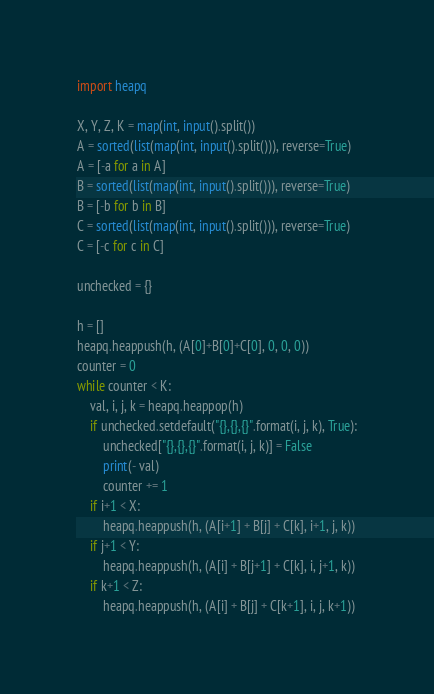<code> <loc_0><loc_0><loc_500><loc_500><_Python_>import heapq

X, Y, Z, K = map(int, input().split())
A = sorted(list(map(int, input().split())), reverse=True)
A = [-a for a in A]
B = sorted(list(map(int, input().split())), reverse=True)
B = [-b for b in B]
C = sorted(list(map(int, input().split())), reverse=True)
C = [-c for c in C]

unchecked = {}

h = []
heapq.heappush(h, (A[0]+B[0]+C[0], 0, 0, 0))
counter = 0
while counter < K:
    val, i, j, k = heapq.heappop(h)
    if unchecked.setdefault("{},{},{}".format(i, j, k), True):
        unchecked["{},{},{}".format(i, j, k)] = False
        print(- val)
        counter += 1
    if i+1 < X:
        heapq.heappush(h, (A[i+1] + B[j] + C[k], i+1, j, k))
    if j+1 < Y:
        heapq.heappush(h, (A[i] + B[j+1] + C[k], i, j+1, k))
    if k+1 < Z:
        heapq.heappush(h, (A[i] + B[j] + C[k+1], i, j, k+1))</code> 